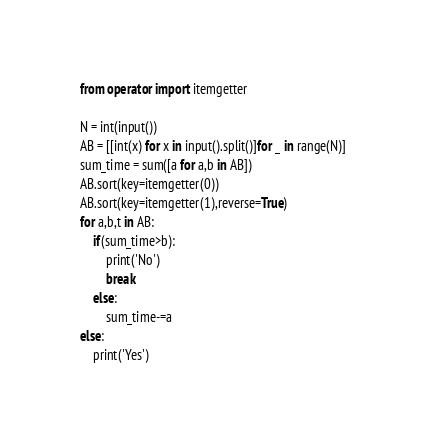<code> <loc_0><loc_0><loc_500><loc_500><_Python_>from operator import itemgetter

N = int(input())
AB = [[int(x) for x in input().split()]for _ in range(N)]
sum_time = sum([a for a,b in AB])
AB.sort(key=itemgetter(0))
AB.sort(key=itemgetter(1),reverse=True)
for a,b,t in AB:
    if(sum_time>b):
        print('No')
        break
    else:
        sum_time-=a
else:
    print('Yes')
</code> 